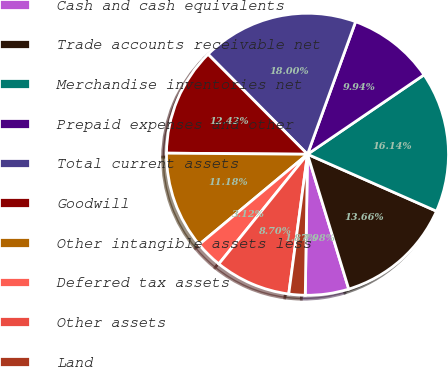Convert chart. <chart><loc_0><loc_0><loc_500><loc_500><pie_chart><fcel>Cash and cash equivalents<fcel>Trade accounts receivable net<fcel>Merchandise inventories net<fcel>Prepaid expenses and other<fcel>Total current assets<fcel>Goodwill<fcel>Other intangible assets less<fcel>Deferred tax assets<fcel>Other assets<fcel>Land<nl><fcel>4.98%<fcel>13.66%<fcel>16.14%<fcel>9.94%<fcel>18.0%<fcel>12.42%<fcel>11.18%<fcel>3.12%<fcel>8.7%<fcel>1.87%<nl></chart> 